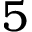Convert formula to latex. <formula><loc_0><loc_0><loc_500><loc_500>5</formula> 